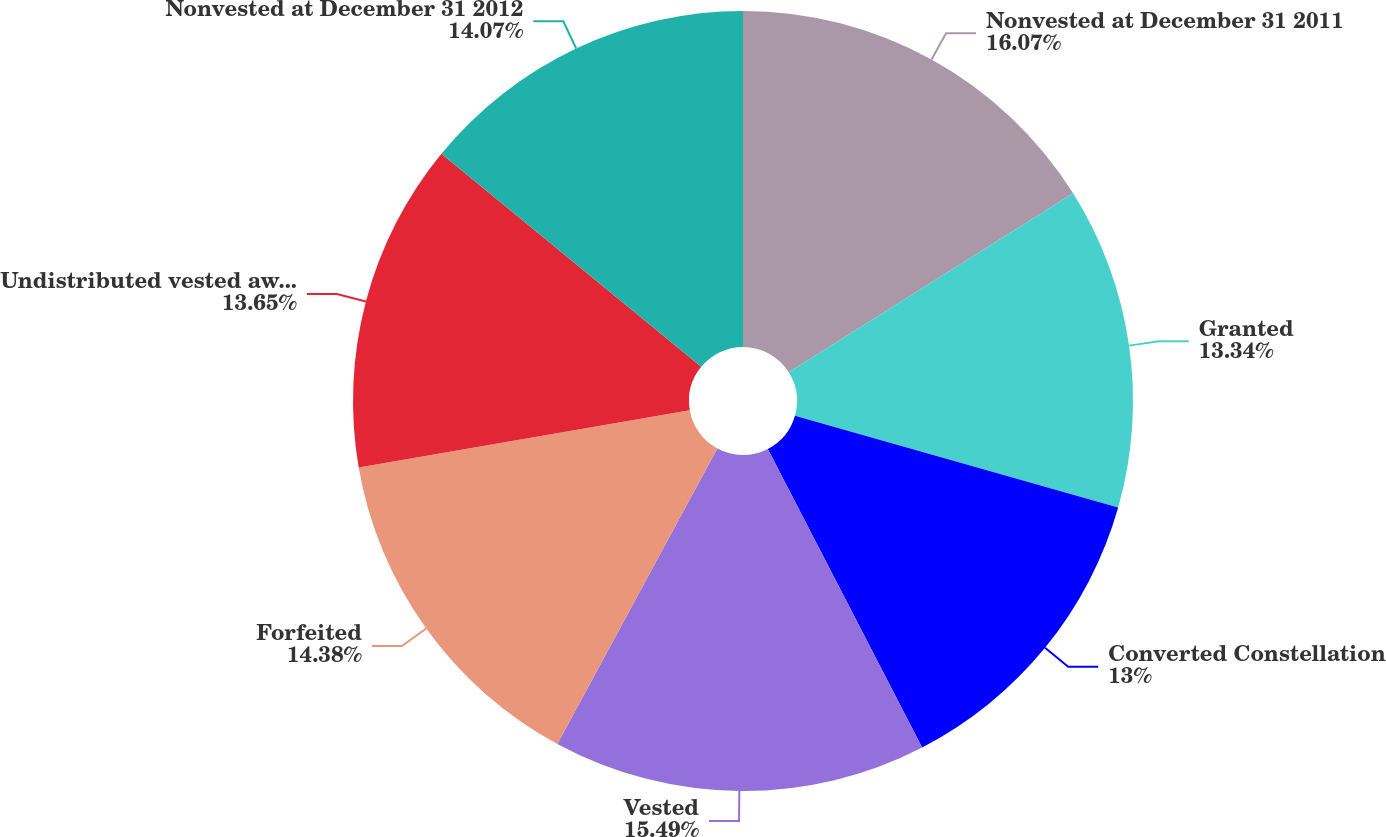Convert chart to OTSL. <chart><loc_0><loc_0><loc_500><loc_500><pie_chart><fcel>Nonvested at December 31 2011<fcel>Granted<fcel>Converted Constellation<fcel>Vested<fcel>Forfeited<fcel>Undistributed vested awards<fcel>Nonvested at December 31 2012<nl><fcel>16.06%<fcel>13.34%<fcel>13.0%<fcel>15.49%<fcel>14.38%<fcel>13.65%<fcel>14.07%<nl></chart> 